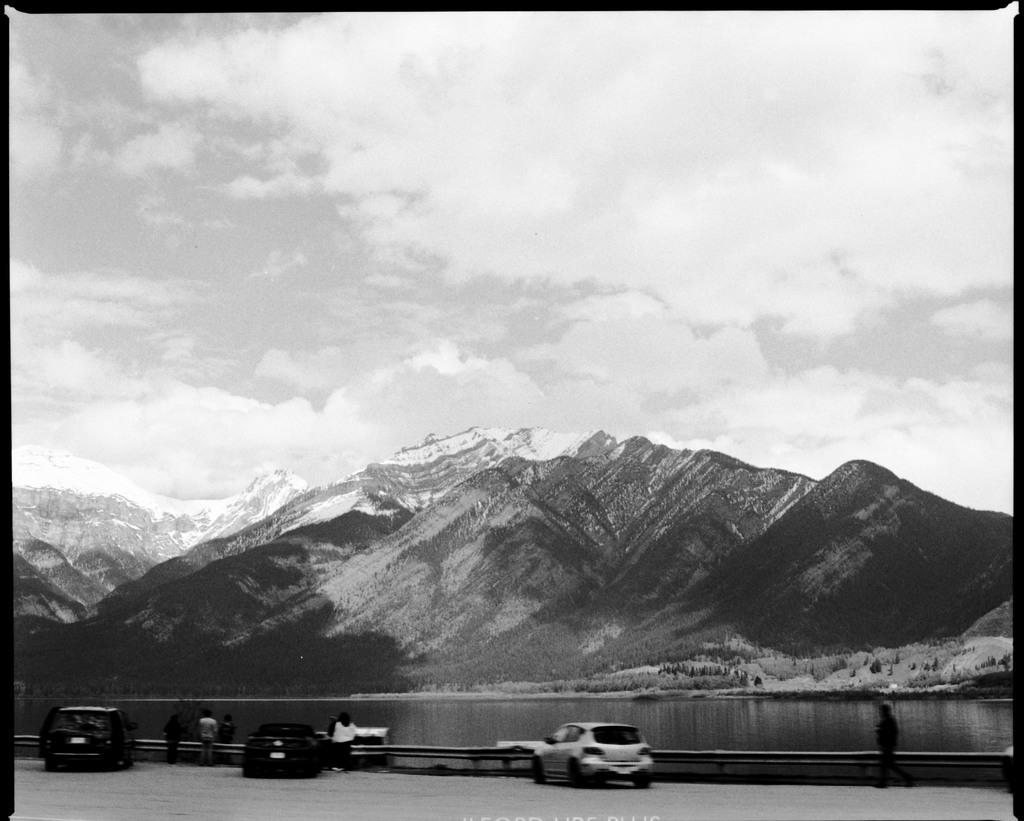What can be seen in the sky in the image? The sky with clouds is visible in the image. What type of natural landform is present in the image? There are mountains in the image. What type of vegetation is present in the image? Trees are present in the image. What type of water body is visible in the image? There is water visible in the image. What type of man-made objects are present in the image? Motor vehicles are in the image. What type of barrier is present in the image? A fence is present in the image. What type of living beings are standing on the ground in the image? Persons are standing on the ground in the image. What type of fifth is present in the image? There is no mention of a "fifth" in the image or the provided facts. What type of road can be seen in the image? There is no road present in the image; it features a sky with clouds, mountains, trees, water, motor vehicles, a fence, and persons. 